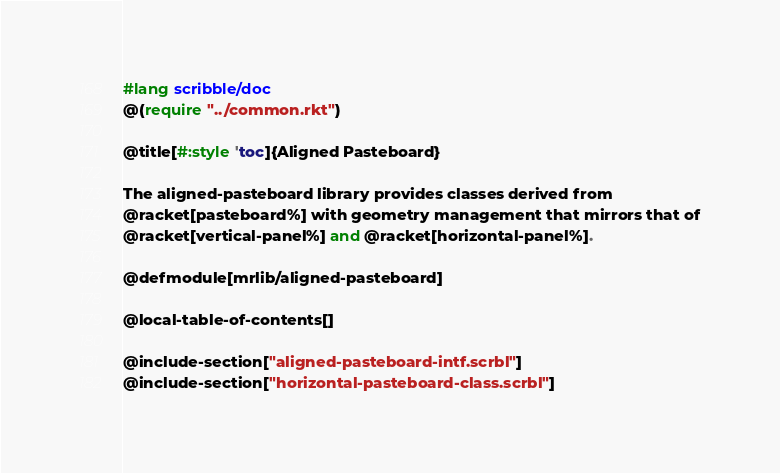<code> <loc_0><loc_0><loc_500><loc_500><_Racket_>#lang scribble/doc
@(require "../common.rkt")

@title[#:style 'toc]{Aligned Pasteboard}

The aligned-pasteboard library provides classes derived from
@racket[pasteboard%] with geometry management that mirrors that of
@racket[vertical-panel%] and @racket[horizontal-panel%].

@defmodule[mrlib/aligned-pasteboard]

@local-table-of-contents[]

@include-section["aligned-pasteboard-intf.scrbl"]
@include-section["horizontal-pasteboard-class.scrbl"]</code> 